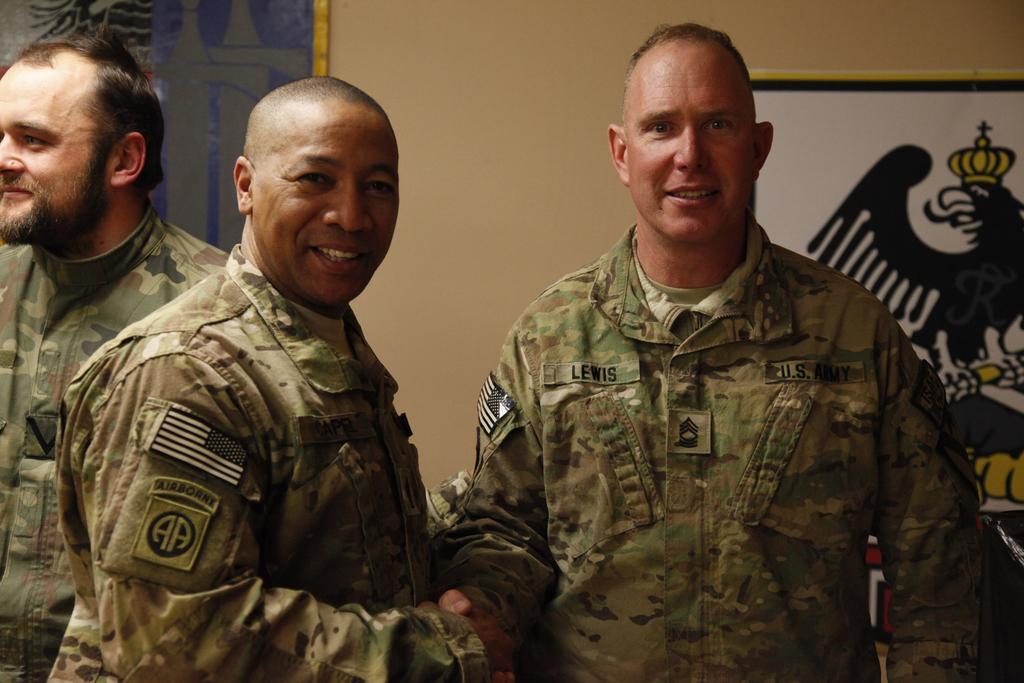How would you summarize this image in a sentence or two? In this picture there are people in the center of the image and there are portraits in the background area of the image. 